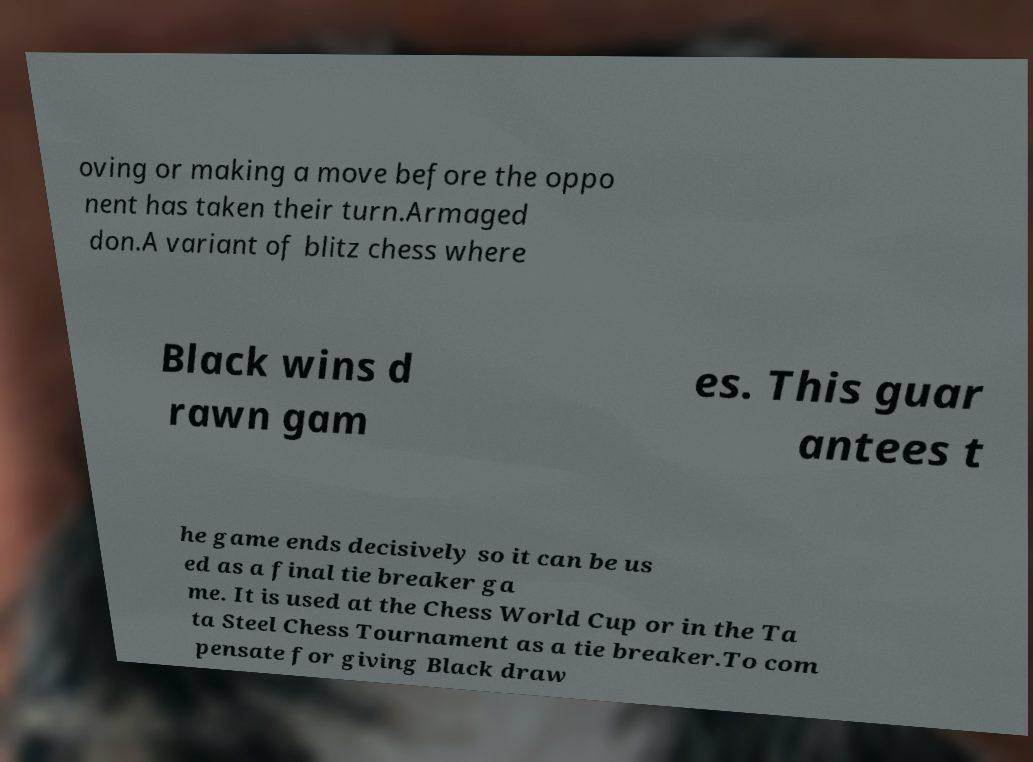Can you read and provide the text displayed in the image?This photo seems to have some interesting text. Can you extract and type it out for me? oving or making a move before the oppo nent has taken their turn.Armaged don.A variant of blitz chess where Black wins d rawn gam es. This guar antees t he game ends decisively so it can be us ed as a final tie breaker ga me. It is used at the Chess World Cup or in the Ta ta Steel Chess Tournament as a tie breaker.To com pensate for giving Black draw 